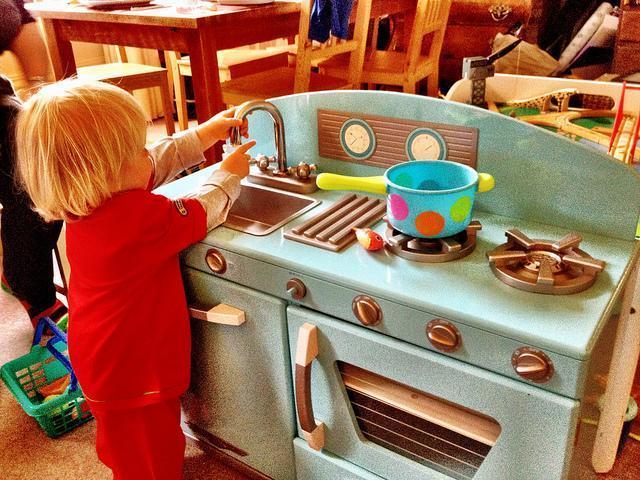Is this affirmation: "The dining table is at the right side of the oven." correct?
Answer yes or no. No. 